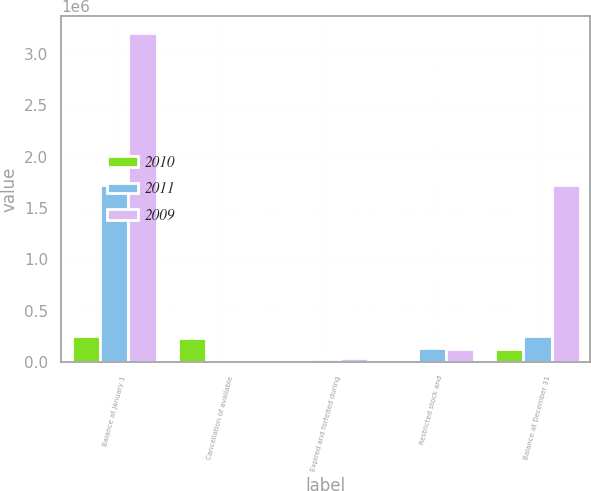<chart> <loc_0><loc_0><loc_500><loc_500><stacked_bar_chart><ecel><fcel>Balance at January 1<fcel>Cancellation of available<fcel>Expired and forfeited during<fcel>Restricted stock and<fcel>Balance at December 31<nl><fcel>2010<fcel>255263<fcel>229333<fcel>0<fcel>19017<fcel>131132<nl><fcel>2011<fcel>1.72454e+06<fcel>0<fcel>26269<fcel>137371<fcel>255263<nl><fcel>2009<fcel>3.20521e+06<fcel>0<fcel>37500<fcel>124894<fcel>1.72454e+06<nl></chart> 